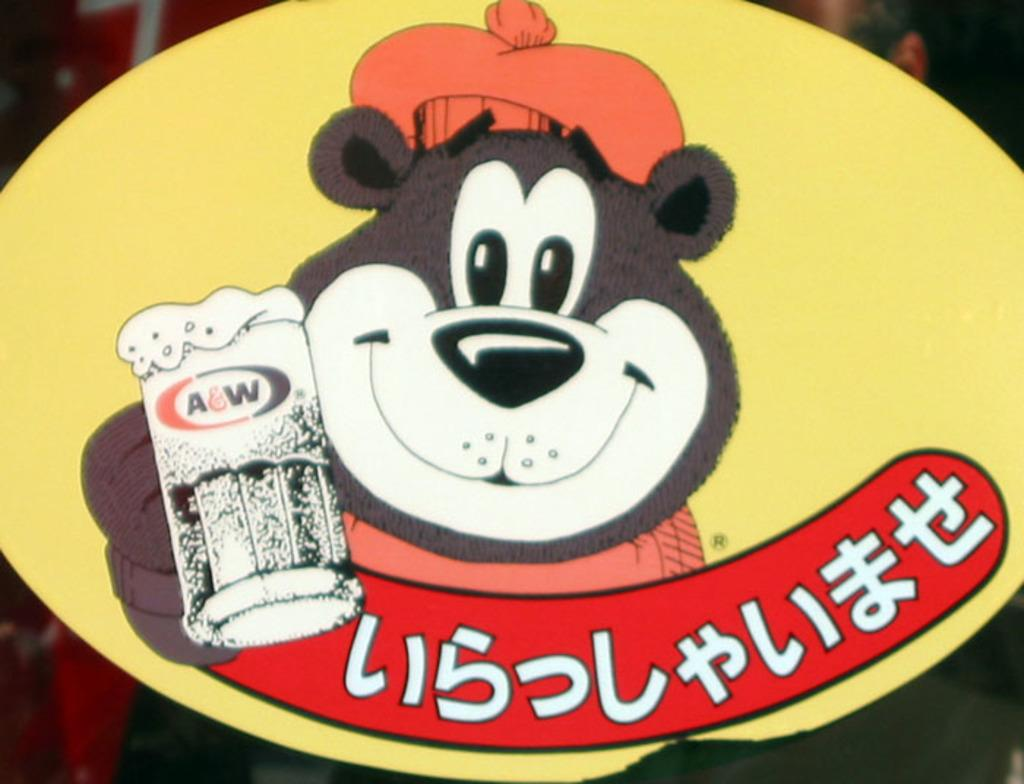What is the main object in the image? There is a board in the image. What is depicted on the board? The board contains a bear cartoon. What is the bear cartoon holding? The bear cartoon is holding a glass. What additional information is present on the board? There is text below the bear cartoon on the board. How does the bear cartoon move around in the image? The bear cartoon does not move around in the image; it is a static image on the board. 